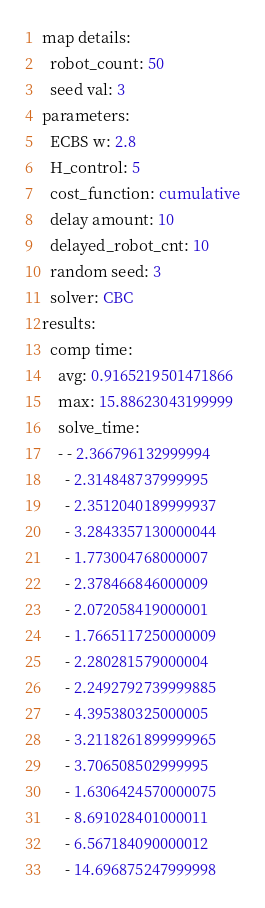<code> <loc_0><loc_0><loc_500><loc_500><_YAML_>map details:
  robot_count: 50
  seed val: 3
parameters:
  ECBS w: 2.8
  H_control: 5
  cost_function: cumulative
  delay amount: 10
  delayed_robot_cnt: 10
  random seed: 3
  solver: CBC
results:
  comp time:
    avg: 0.9165219501471866
    max: 15.88623043199999
    solve_time:
    - - 2.366796132999994
      - 2.314848737999995
      - 2.3512040189999937
      - 3.2843357130000044
      - 1.773004768000007
      - 2.378466846000009
      - 2.072058419000001
      - 1.7665117250000009
      - 2.280281579000004
      - 2.2492792739999885
      - 4.395380325000005
      - 3.2118261899999965
      - 3.706508502999995
      - 1.6306424570000075
      - 8.691028401000011
      - 6.567184090000012
      - 14.696875247999998</code> 